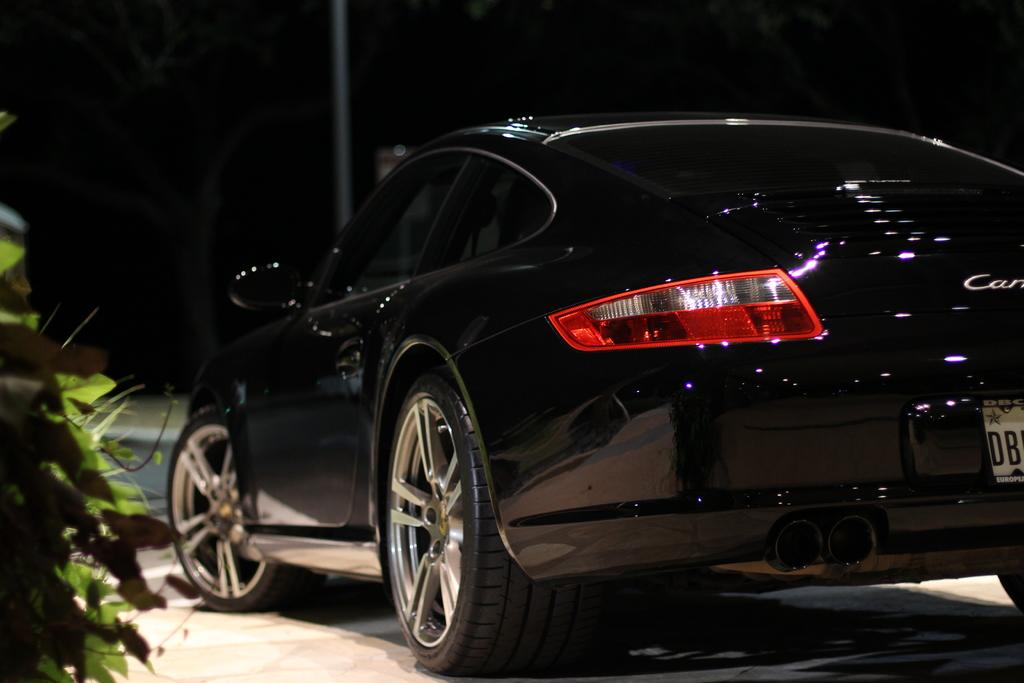What color is the car on the road in the image? The car on the road is black. What can be seen on the left side of the image? There is a plant on the left side of the image. How would you describe the overall lighting in the image? The background of the image is dark. What structures or objects can be seen in the background? There is a pole, a tree, and another object visible in the background. Is the car in the image being attacked by a bat? There is no bat present in the image, and therefore no such attack can be observed. 